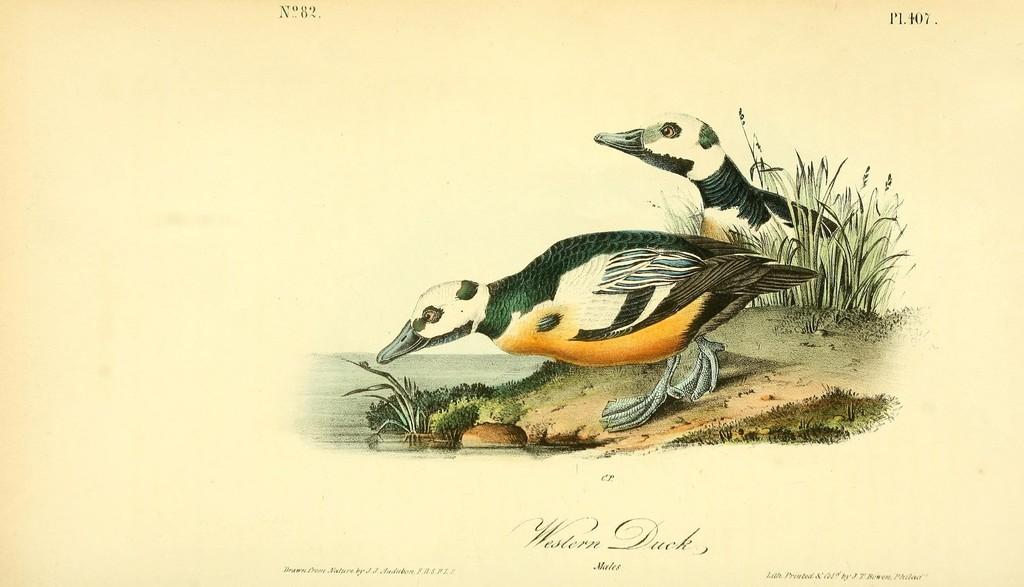What type of artwork is depicted in the image? The image is a painting. What can be seen near the lake in the painting? There are two birds near the lake in the painting. What other elements are included in the painting? The painting includes plants. Can you describe the text in the painting? There is black color text on the paper in the painting. What type of cabbage is growing near the lake in the painting? There is no cabbage present in the painting; it features plants, but no specific type of vegetable is mentioned. What time of day is depicted in the painting? The time of day is not specified in the painting; it could be any time, as there is no indication of morning or any other specific time. 